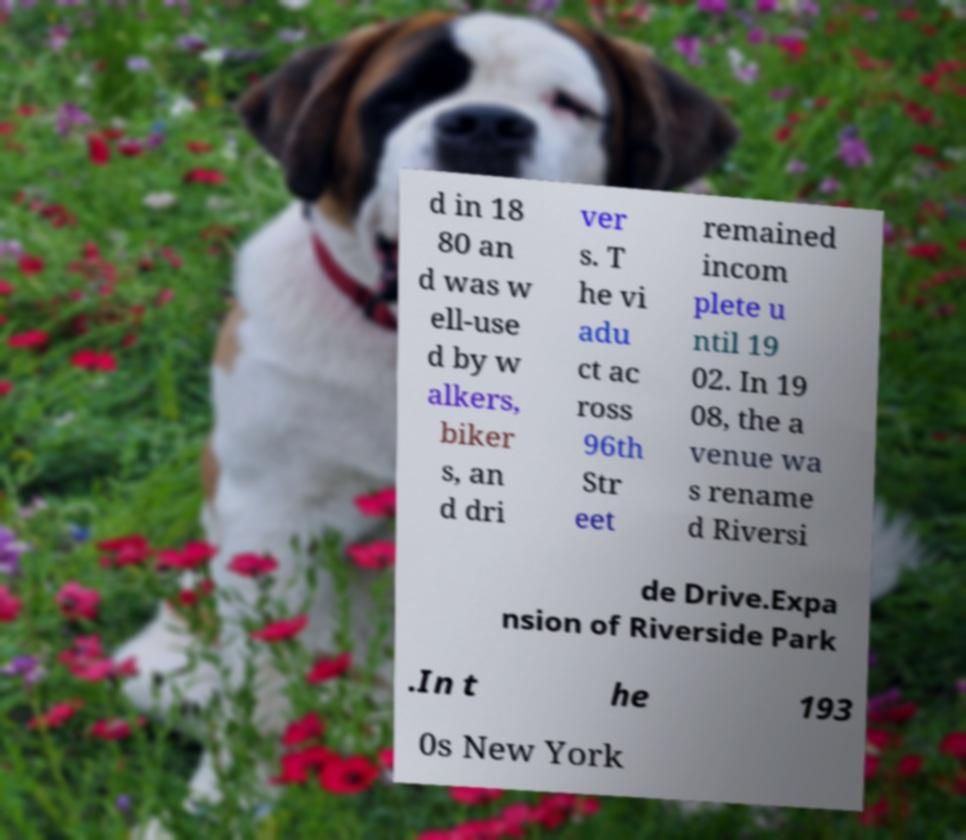Could you assist in decoding the text presented in this image and type it out clearly? d in 18 80 an d was w ell-use d by w alkers, biker s, an d dri ver s. T he vi adu ct ac ross 96th Str eet remained incom plete u ntil 19 02. In 19 08, the a venue wa s rename d Riversi de Drive.Expa nsion of Riverside Park .In t he 193 0s New York 